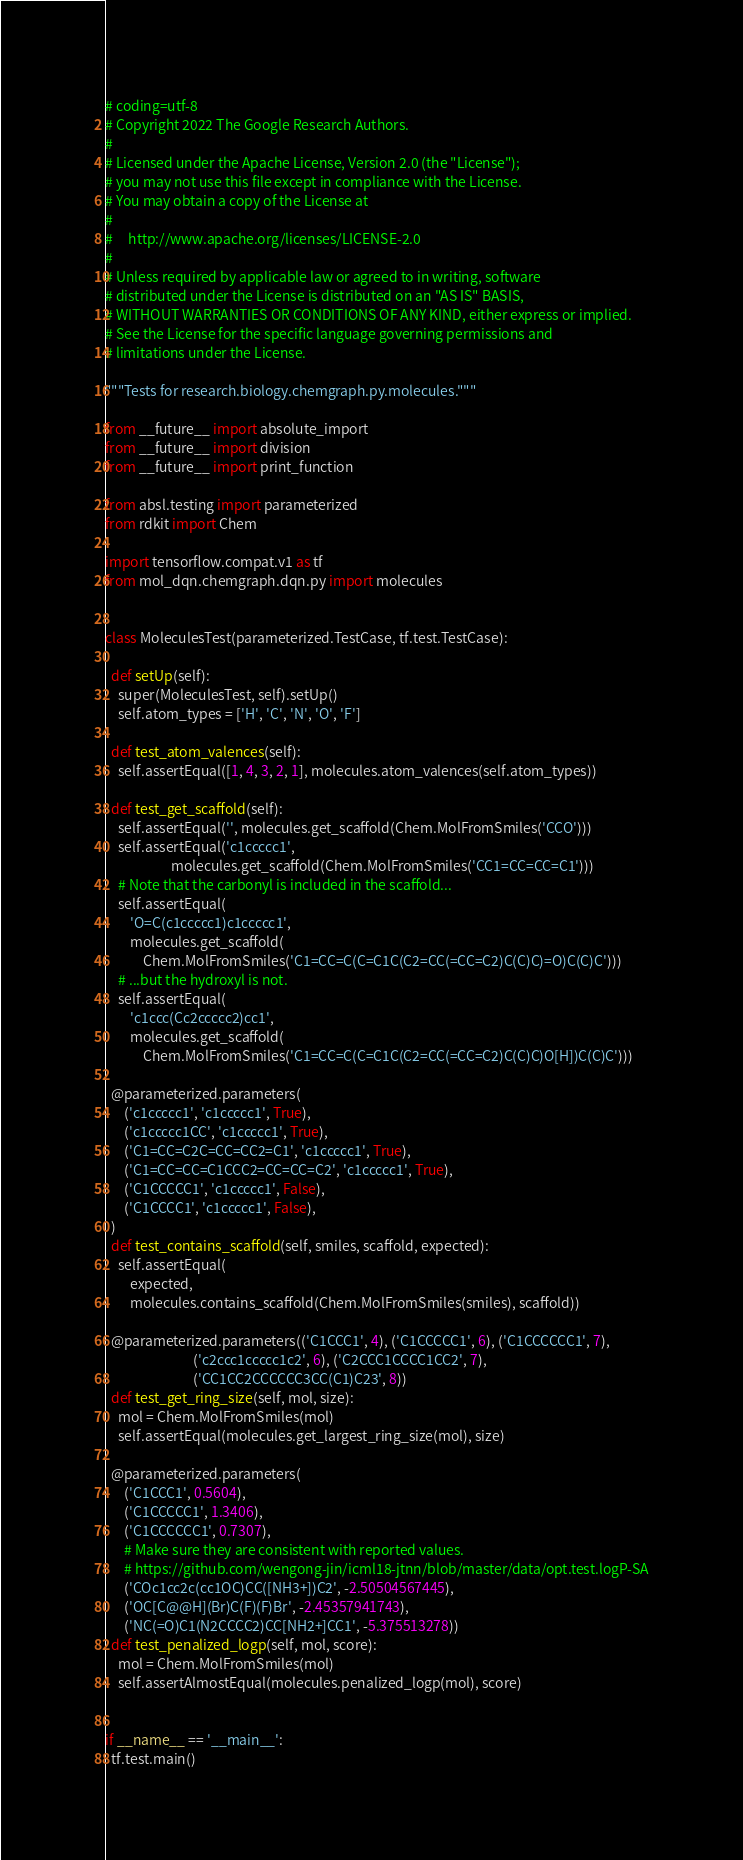Convert code to text. <code><loc_0><loc_0><loc_500><loc_500><_Python_># coding=utf-8
# Copyright 2022 The Google Research Authors.
#
# Licensed under the Apache License, Version 2.0 (the "License");
# you may not use this file except in compliance with the License.
# You may obtain a copy of the License at
#
#     http://www.apache.org/licenses/LICENSE-2.0
#
# Unless required by applicable law or agreed to in writing, software
# distributed under the License is distributed on an "AS IS" BASIS,
# WITHOUT WARRANTIES OR CONDITIONS OF ANY KIND, either express or implied.
# See the License for the specific language governing permissions and
# limitations under the License.

"""Tests for research.biology.chemgraph.py.molecules."""

from __future__ import absolute_import
from __future__ import division
from __future__ import print_function

from absl.testing import parameterized
from rdkit import Chem

import tensorflow.compat.v1 as tf
from mol_dqn.chemgraph.dqn.py import molecules


class MoleculesTest(parameterized.TestCase, tf.test.TestCase):

  def setUp(self):
    super(MoleculesTest, self).setUp()
    self.atom_types = ['H', 'C', 'N', 'O', 'F']

  def test_atom_valences(self):
    self.assertEqual([1, 4, 3, 2, 1], molecules.atom_valences(self.atom_types))

  def test_get_scaffold(self):
    self.assertEqual('', molecules.get_scaffold(Chem.MolFromSmiles('CCO')))
    self.assertEqual('c1ccccc1',
                     molecules.get_scaffold(Chem.MolFromSmiles('CC1=CC=CC=C1')))
    # Note that the carbonyl is included in the scaffold...
    self.assertEqual(
        'O=C(c1ccccc1)c1ccccc1',
        molecules.get_scaffold(
            Chem.MolFromSmiles('C1=CC=C(C=C1C(C2=CC(=CC=C2)C(C)C)=O)C(C)C')))
    # ...but the hydroxyl is not.
    self.assertEqual(
        'c1ccc(Cc2ccccc2)cc1',
        molecules.get_scaffold(
            Chem.MolFromSmiles('C1=CC=C(C=C1C(C2=CC(=CC=C2)C(C)C)O[H])C(C)C')))

  @parameterized.parameters(
      ('c1ccccc1', 'c1ccccc1', True),
      ('c1ccccc1CC', 'c1ccccc1', True),
      ('C1=CC=C2C=CC=CC2=C1', 'c1ccccc1', True),
      ('C1=CC=CC=C1CCC2=CC=CC=C2', 'c1ccccc1', True),
      ('C1CCCCC1', 'c1ccccc1', False),
      ('C1CCCC1', 'c1ccccc1', False),
  )
  def test_contains_scaffold(self, smiles, scaffold, expected):
    self.assertEqual(
        expected,
        molecules.contains_scaffold(Chem.MolFromSmiles(smiles), scaffold))

  @parameterized.parameters(('C1CCC1', 4), ('C1CCCCC1', 6), ('C1CCCCCC1', 7),
                            ('c2ccc1ccccc1c2', 6), ('C2CCC1CCCC1CC2', 7),
                            ('CC1CC2CCCCCC3CC(C1)C23', 8))
  def test_get_ring_size(self, mol, size):
    mol = Chem.MolFromSmiles(mol)
    self.assertEqual(molecules.get_largest_ring_size(mol), size)

  @parameterized.parameters(
      ('C1CCC1', 0.5604),
      ('C1CCCCC1', 1.3406),
      ('C1CCCCCC1', 0.7307),
      # Make sure they are consistent with reported values.
      # https://github.com/wengong-jin/icml18-jtnn/blob/master/data/opt.test.logP-SA
      ('COc1cc2c(cc1OC)CC([NH3+])C2', -2.50504567445),
      ('OC[C@@H](Br)C(F)(F)Br', -2.45357941743),
      ('NC(=O)C1(N2CCCC2)CC[NH2+]CC1', -5.375513278))
  def test_penalized_logp(self, mol, score):
    mol = Chem.MolFromSmiles(mol)
    self.assertAlmostEqual(molecules.penalized_logp(mol), score)


if __name__ == '__main__':
  tf.test.main()
</code> 